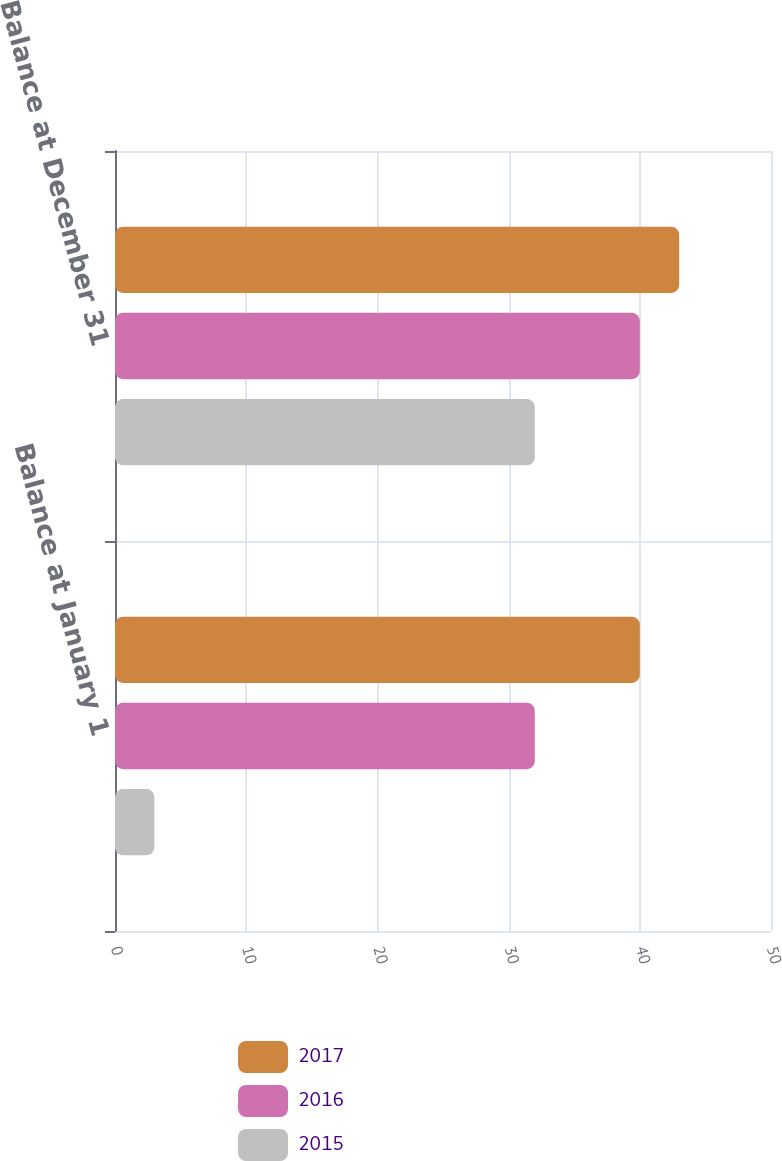Convert chart to OTSL. <chart><loc_0><loc_0><loc_500><loc_500><stacked_bar_chart><ecel><fcel>Balance at January 1<fcel>Balance at December 31<nl><fcel>2017<fcel>40<fcel>43<nl><fcel>2016<fcel>32<fcel>40<nl><fcel>2015<fcel>3<fcel>32<nl></chart> 